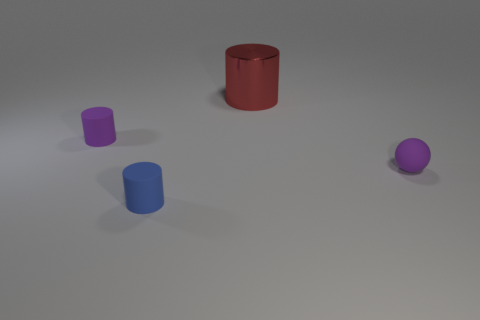What number of tiny matte things have the same color as the tiny rubber sphere?
Ensure brevity in your answer.  1. Is the color of the tiny ball the same as the small thing behind the sphere?
Your answer should be very brief. Yes. Do the rubber object that is behind the small sphere and the matte ball have the same color?
Your response must be concise. Yes. Are there any tiny cylinders of the same color as the matte sphere?
Make the answer very short. Yes. The small rubber thing that is the same color as the small matte ball is what shape?
Keep it short and to the point. Cylinder. Is there any other thing that has the same material as the red object?
Make the answer very short. No. Is the material of the purple thing on the right side of the big red shiny cylinder the same as the large red cylinder?
Provide a short and direct response. No. Is there a tiny blue object that has the same shape as the red thing?
Your answer should be very brief. Yes. Are there the same number of small purple cylinders that are in front of the tiny purple sphere and small purple matte cylinders?
Keep it short and to the point. No. What material is the big thing on the left side of the purple thing that is on the right side of the blue object?
Ensure brevity in your answer.  Metal. 